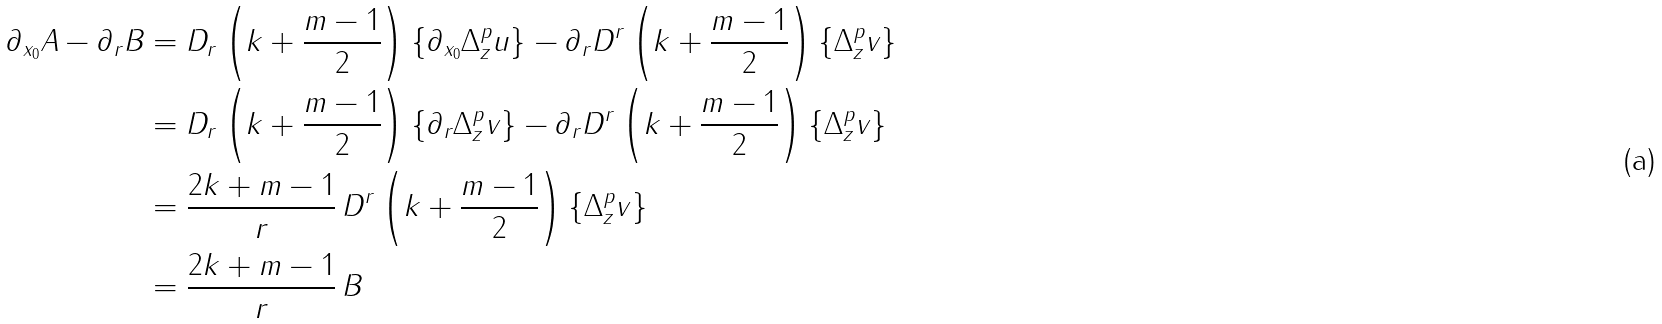<formula> <loc_0><loc_0><loc_500><loc_500>\partial _ { x _ { 0 } } A - \partial _ { r } B & = D _ { r } \left ( k + \frac { m - 1 } { 2 } \right ) \{ \partial _ { x _ { 0 } } \Delta _ { z } ^ { p } u \} - \partial _ { r } D ^ { r } \left ( k + \frac { m - 1 } { 2 } \right ) \{ \Delta _ { z } ^ { p } v \} \\ & = D _ { r } \left ( k + \frac { m - 1 } { 2 } \right ) \{ \partial _ { r } \Delta _ { z } ^ { p } v \} - \partial _ { r } D ^ { r } \left ( k + \frac { m - 1 } { 2 } \right ) \{ \Delta _ { z } ^ { p } v \} \\ & = \frac { 2 k + m - 1 } { r } \, D ^ { r } \left ( k + \frac { m - 1 } { 2 } \right ) \{ \Delta _ { z } ^ { p } v \} \\ & = \frac { 2 k + m - 1 } { r } \, B</formula> 